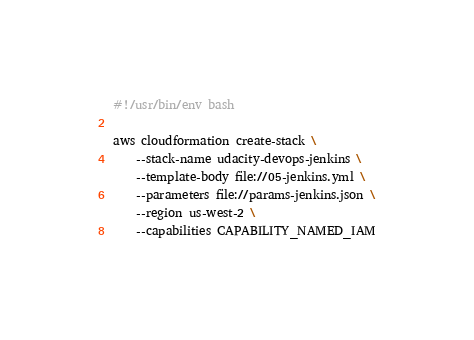Convert code to text. <code><loc_0><loc_0><loc_500><loc_500><_Bash_>#!/usr/bin/env bash

aws cloudformation create-stack \
    --stack-name udacity-devops-jenkins \
    --template-body file://05-jenkins.yml \
    --parameters file://params-jenkins.json \
    --region us-west-2 \
    --capabilities CAPABILITY_NAMED_IAM
</code> 